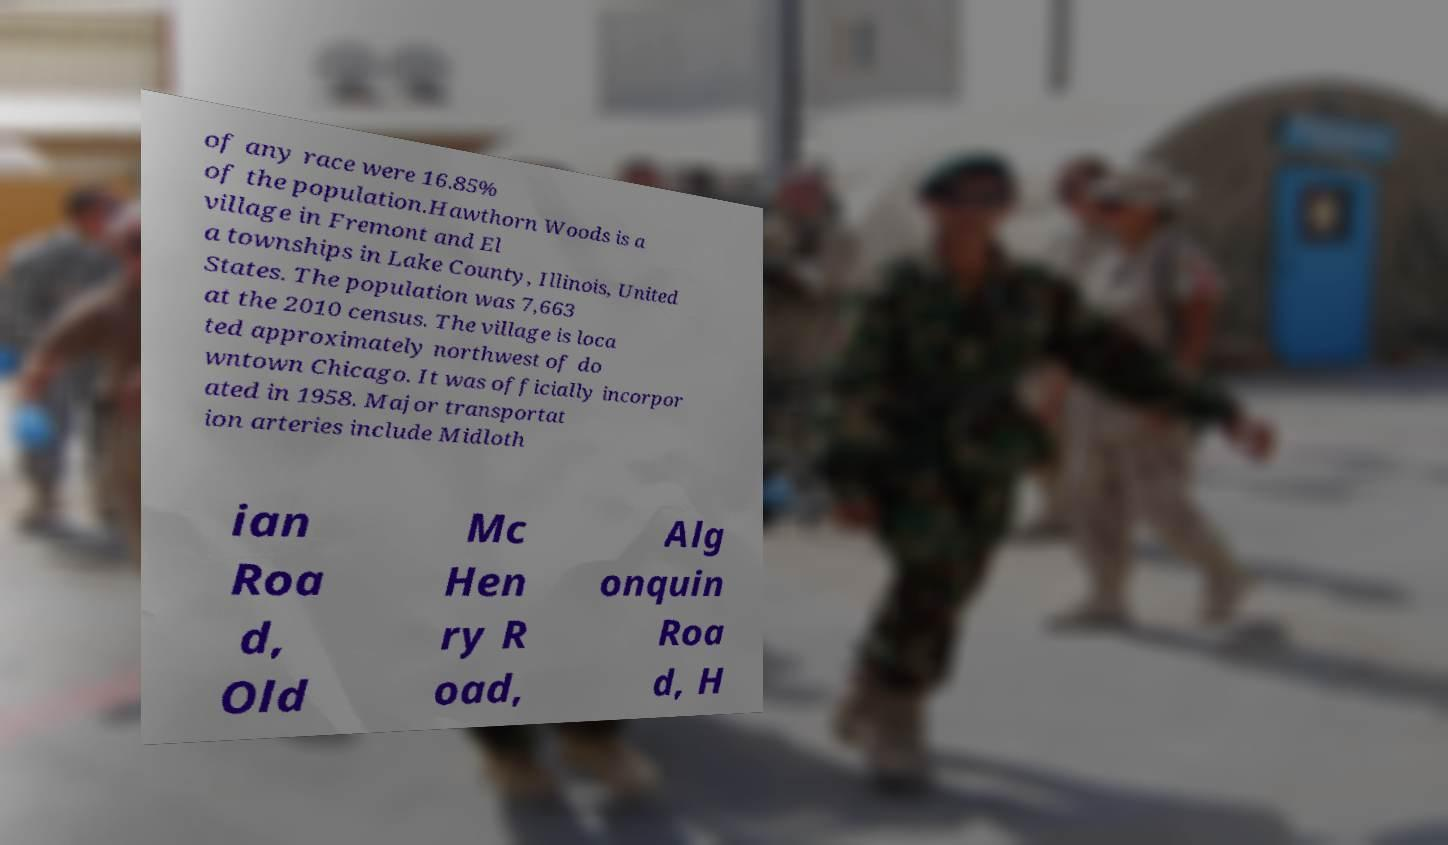There's text embedded in this image that I need extracted. Can you transcribe it verbatim? of any race were 16.85% of the population.Hawthorn Woods is a village in Fremont and El a townships in Lake County, Illinois, United States. The population was 7,663 at the 2010 census. The village is loca ted approximately northwest of do wntown Chicago. It was officially incorpor ated in 1958. Major transportat ion arteries include Midloth ian Roa d, Old Mc Hen ry R oad, Alg onquin Roa d, H 